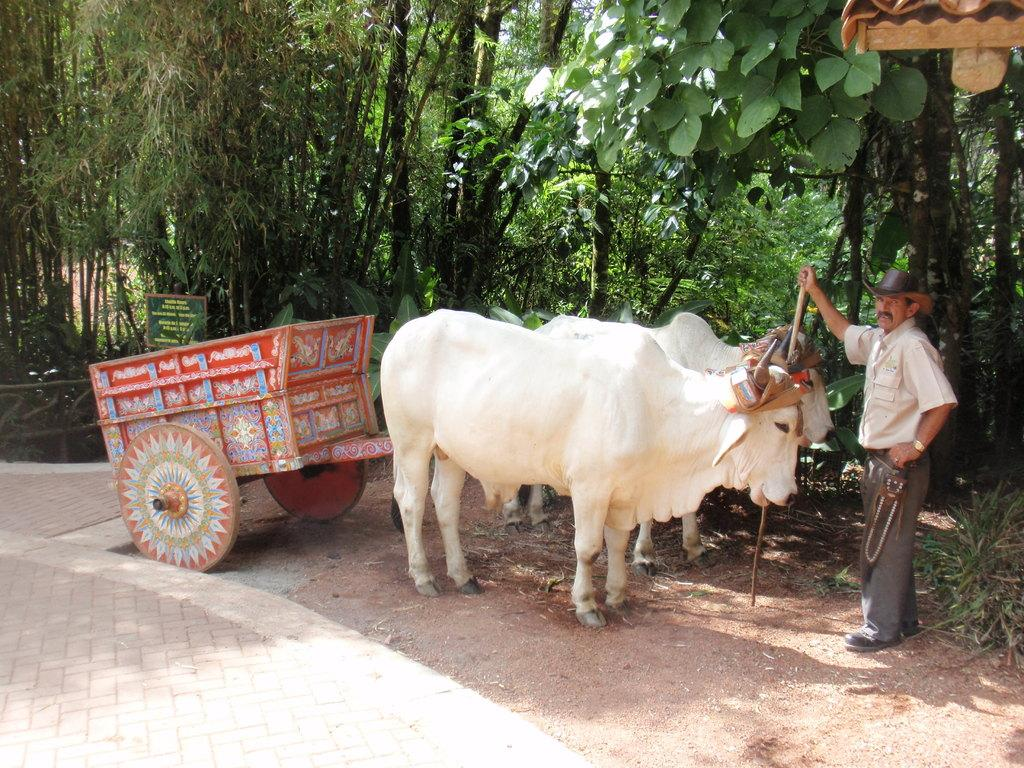What is the main subject of the image? The main subject of the image is a bullock cart. Can you describe the person in the image? There is a person on the ground in the image. What can be seen in the background of the image? There are trees and unspecified objects in the background of the image. What type of rhythm is the bullock cart producing in the image? The bullock cart does not produce a rhythm in the image; it is a stationary object. What kind of beast is the person interacting with in the image? There is no beast present in the image; the person is on the ground near the bullock cart. 